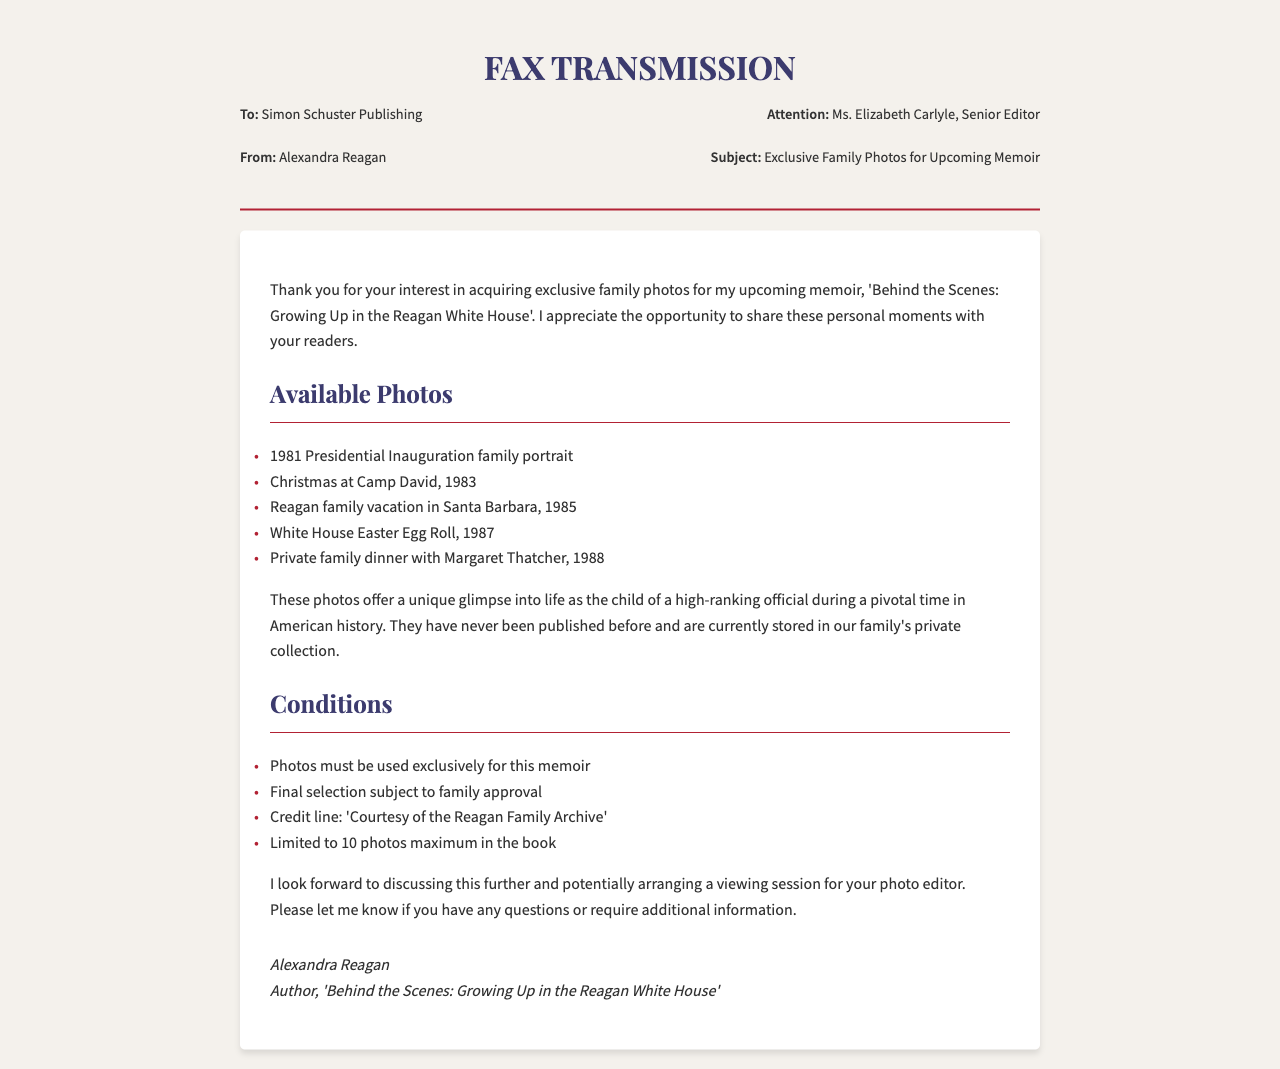What is the title of the memoir? The title of the memoir is mentioned in the document as 'Behind the Scenes: Growing Up in the Reagan White House'.
Answer: 'Behind the Scenes: Growing Up in the Reagan White House' Who is the recipient of the fax? The recipient of the fax is specified in the document as Simon Schuster Publishing.
Answer: Simon Schuster Publishing What year was the Presidential Inauguration family portrait taken? The year the Presidential Inauguration family portrait was taken is indicated as 1981.
Answer: 1981 How many photos are limited for use in the book? The document states that the limited number of photos for use in the book is 10.
Answer: 10 What event do the photos provide a glimpse into? The photos provide a glimpse into life as the child of a high-ranking official during a pivotal time in American history.
Answer: Life as the child of a high-ranking official What is required for the photos to be used? The document specifies a condition that photos must be used exclusively for the memoir.
Answer: Exclusively for this memoir What is the name of the Senior Editor? The name of the Senior Editor mentioned in the document is Ms. Elizabeth Carlyle.
Answer: Ms. Elizabeth Carlyle What is the signature of the sender? The signature of the sender as indicated in the document is Alexandra Reagan.
Answer: Alexandra Reagan What year does the document reflect on an Easter Egg Roll? The year mentioned for the White House Easter Egg Roll is 1987.
Answer: 1987 